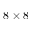Convert formula to latex. <formula><loc_0><loc_0><loc_500><loc_500>8 \times 8</formula> 